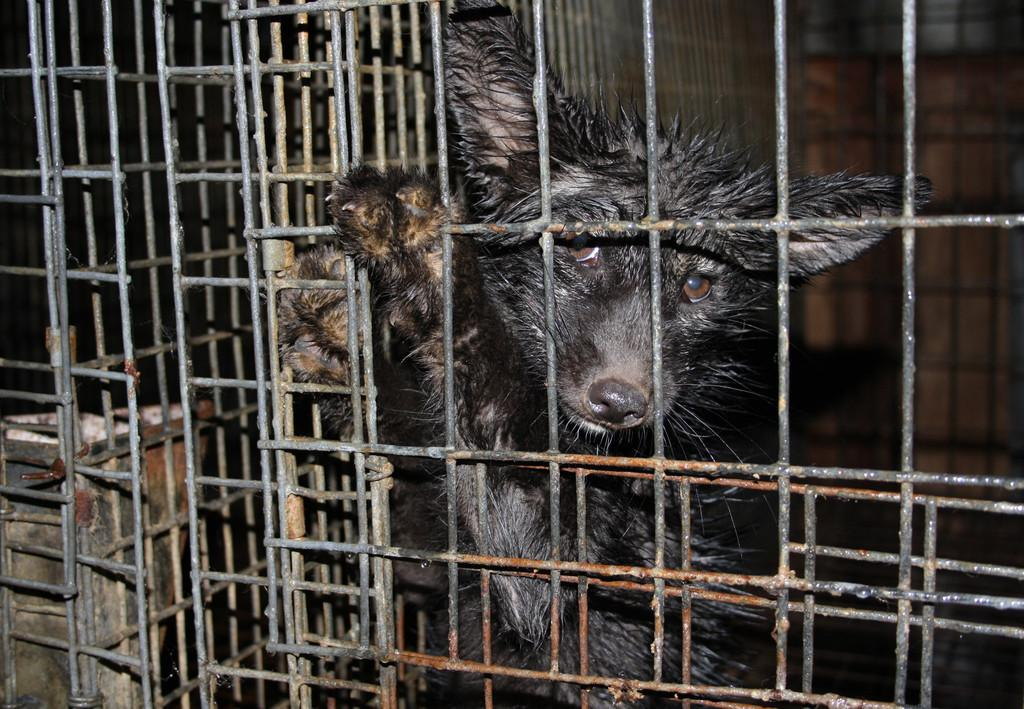What is the main subject in the center of the image? There is an animal in the center of the image. What is the condition of the animal in the image? The animal is in a cage. Can you describe the background of the image? There might be a wall in the background of the image. What type of fowl is perched on the animal's tongue in the image? There is no fowl present in the image, nor is there any mention of a tongue. 